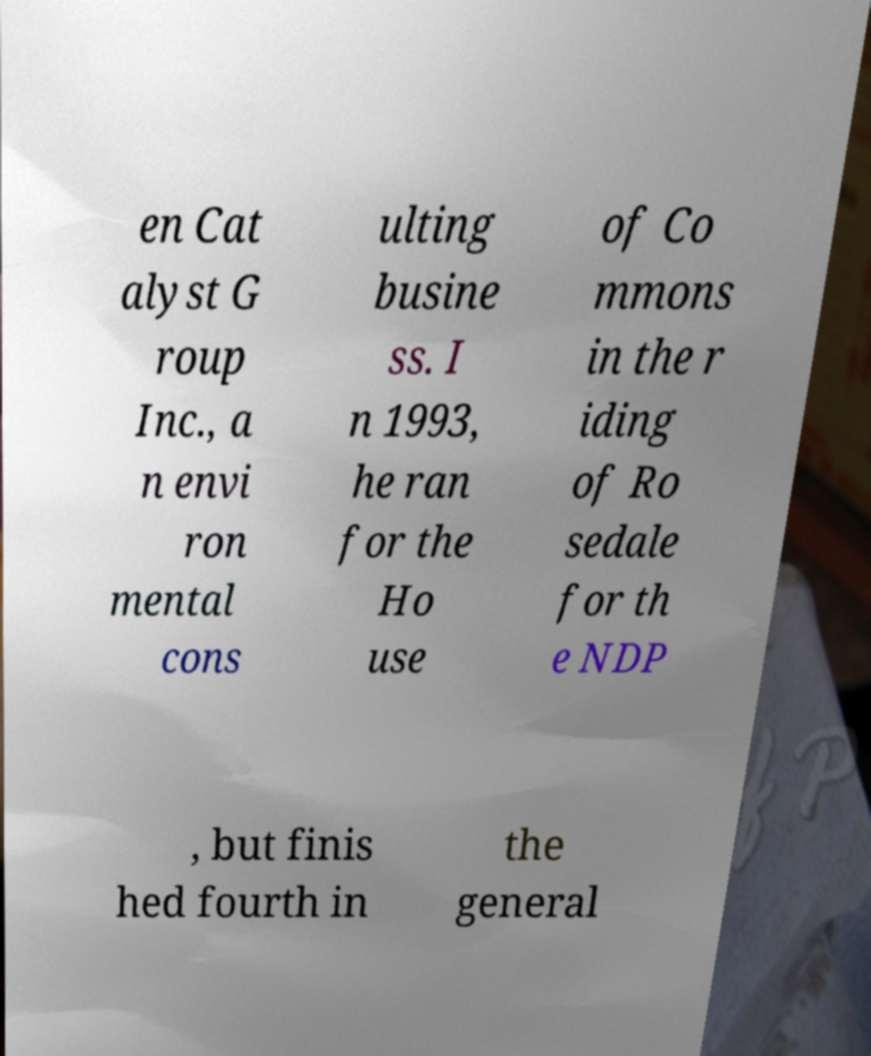I need the written content from this picture converted into text. Can you do that? en Cat alyst G roup Inc., a n envi ron mental cons ulting busine ss. I n 1993, he ran for the Ho use of Co mmons in the r iding of Ro sedale for th e NDP , but finis hed fourth in the general 